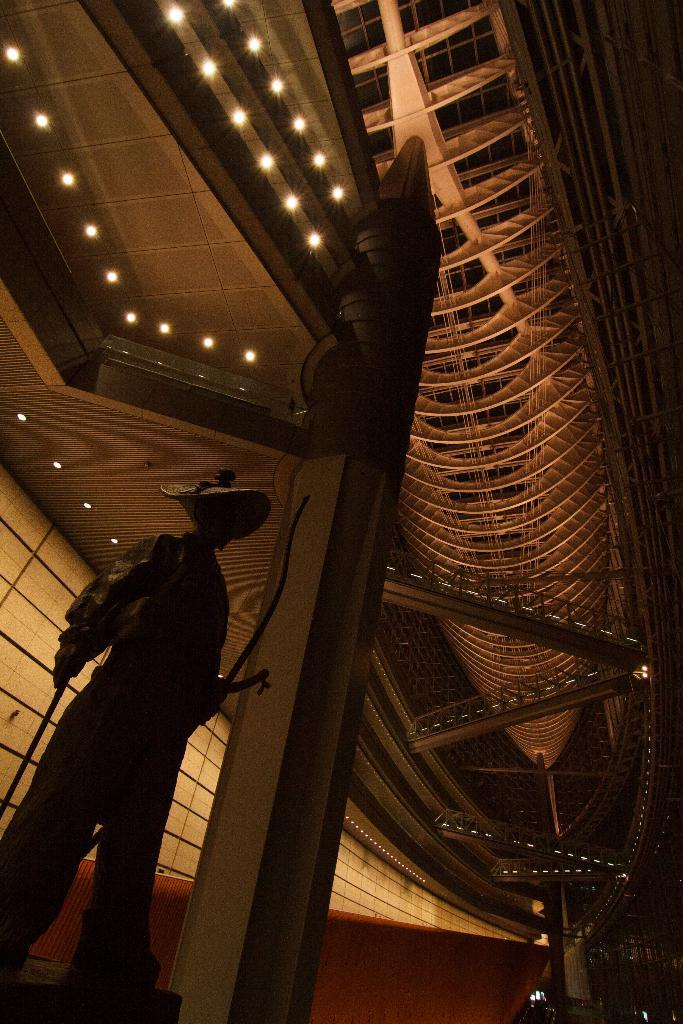What is the main subject in the foreground of the image? There is a statue of a person in the foreground of the image. What can be seen in the background of the image? There is a building with lights in the background of the image. What type of hammer is being used to fold the parcel in the image? There is no hammer or parcel present in the image; it only features a statue of a person and a building with lights. 